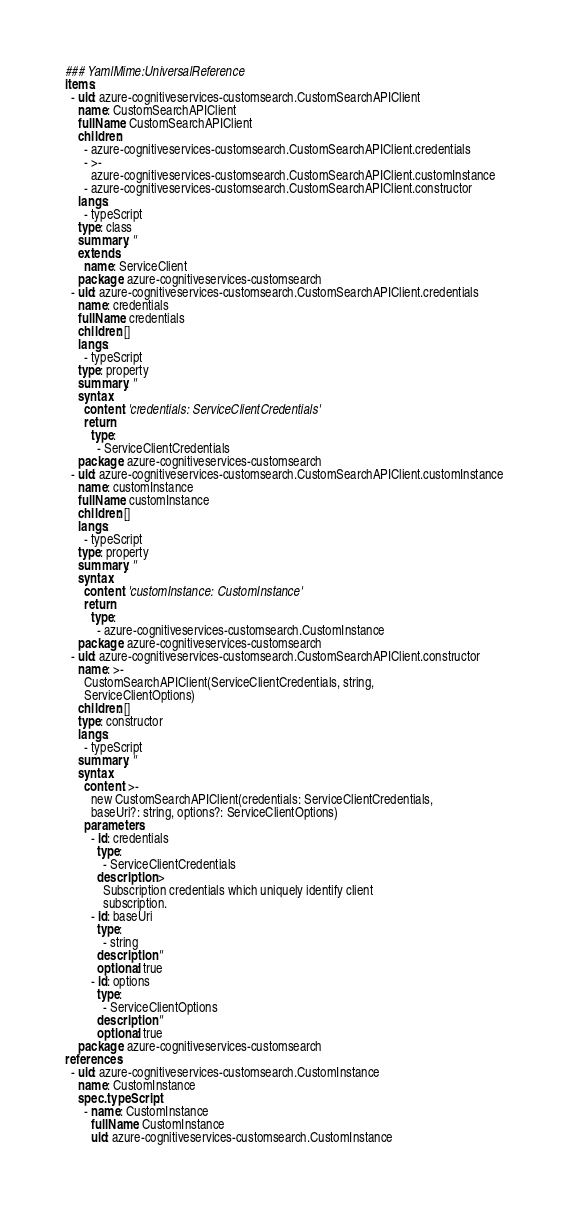Convert code to text. <code><loc_0><loc_0><loc_500><loc_500><_YAML_>### YamlMime:UniversalReference
items:
  - uid: azure-cognitiveservices-customsearch.CustomSearchAPIClient
    name: CustomSearchAPIClient
    fullName: CustomSearchAPIClient
    children:
      - azure-cognitiveservices-customsearch.CustomSearchAPIClient.credentials
      - >-
        azure-cognitiveservices-customsearch.CustomSearchAPIClient.customInstance
      - azure-cognitiveservices-customsearch.CustomSearchAPIClient.constructor
    langs:
      - typeScript
    type: class
    summary: ''
    extends:
      name: ServiceClient
    package: azure-cognitiveservices-customsearch
  - uid: azure-cognitiveservices-customsearch.CustomSearchAPIClient.credentials
    name: credentials
    fullName: credentials
    children: []
    langs:
      - typeScript
    type: property
    summary: ''
    syntax:
      content: 'credentials: ServiceClientCredentials'
      return:
        type:
          - ServiceClientCredentials
    package: azure-cognitiveservices-customsearch
  - uid: azure-cognitiveservices-customsearch.CustomSearchAPIClient.customInstance
    name: customInstance
    fullName: customInstance
    children: []
    langs:
      - typeScript
    type: property
    summary: ''
    syntax:
      content: 'customInstance: CustomInstance'
      return:
        type:
          - azure-cognitiveservices-customsearch.CustomInstance
    package: azure-cognitiveservices-customsearch
  - uid: azure-cognitiveservices-customsearch.CustomSearchAPIClient.constructor
    name: >-
      CustomSearchAPIClient(ServiceClientCredentials, string,
      ServiceClientOptions)
    children: []
    type: constructor
    langs:
      - typeScript
    summary: ''
    syntax:
      content: >-
        new CustomSearchAPIClient(credentials: ServiceClientCredentials,
        baseUri?: string, options?: ServiceClientOptions)
      parameters:
        - id: credentials
          type:
            - ServiceClientCredentials
          description: >
            Subscription credentials which uniquely identify client
            subscription.
        - id: baseUri
          type:
            - string
          description: ''
          optional: true
        - id: options
          type:
            - ServiceClientOptions
          description: ''
          optional: true
    package: azure-cognitiveservices-customsearch
references:
  - uid: azure-cognitiveservices-customsearch.CustomInstance
    name: CustomInstance
    spec.typeScript:
      - name: CustomInstance
        fullName: CustomInstance
        uid: azure-cognitiveservices-customsearch.CustomInstance
</code> 